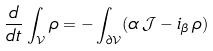Convert formula to latex. <formula><loc_0><loc_0><loc_500><loc_500>\frac { d } { d t } \int _ { \mathcal { V } } \rho = - \int _ { \partial \mathcal { V } } ( \alpha \, \mathcal { J } - i _ { \beta } \, \rho )</formula> 